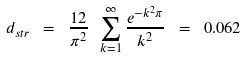<formula> <loc_0><loc_0><loc_500><loc_500>d _ { s t r } \ = \ \frac { 1 2 } { \pi ^ { 2 } } \ \sum _ { k = 1 } ^ { \infty } \frac { e ^ { - k ^ { 2 } \pi } } { k ^ { 2 } } \ = \ 0 . 0 6 2</formula> 